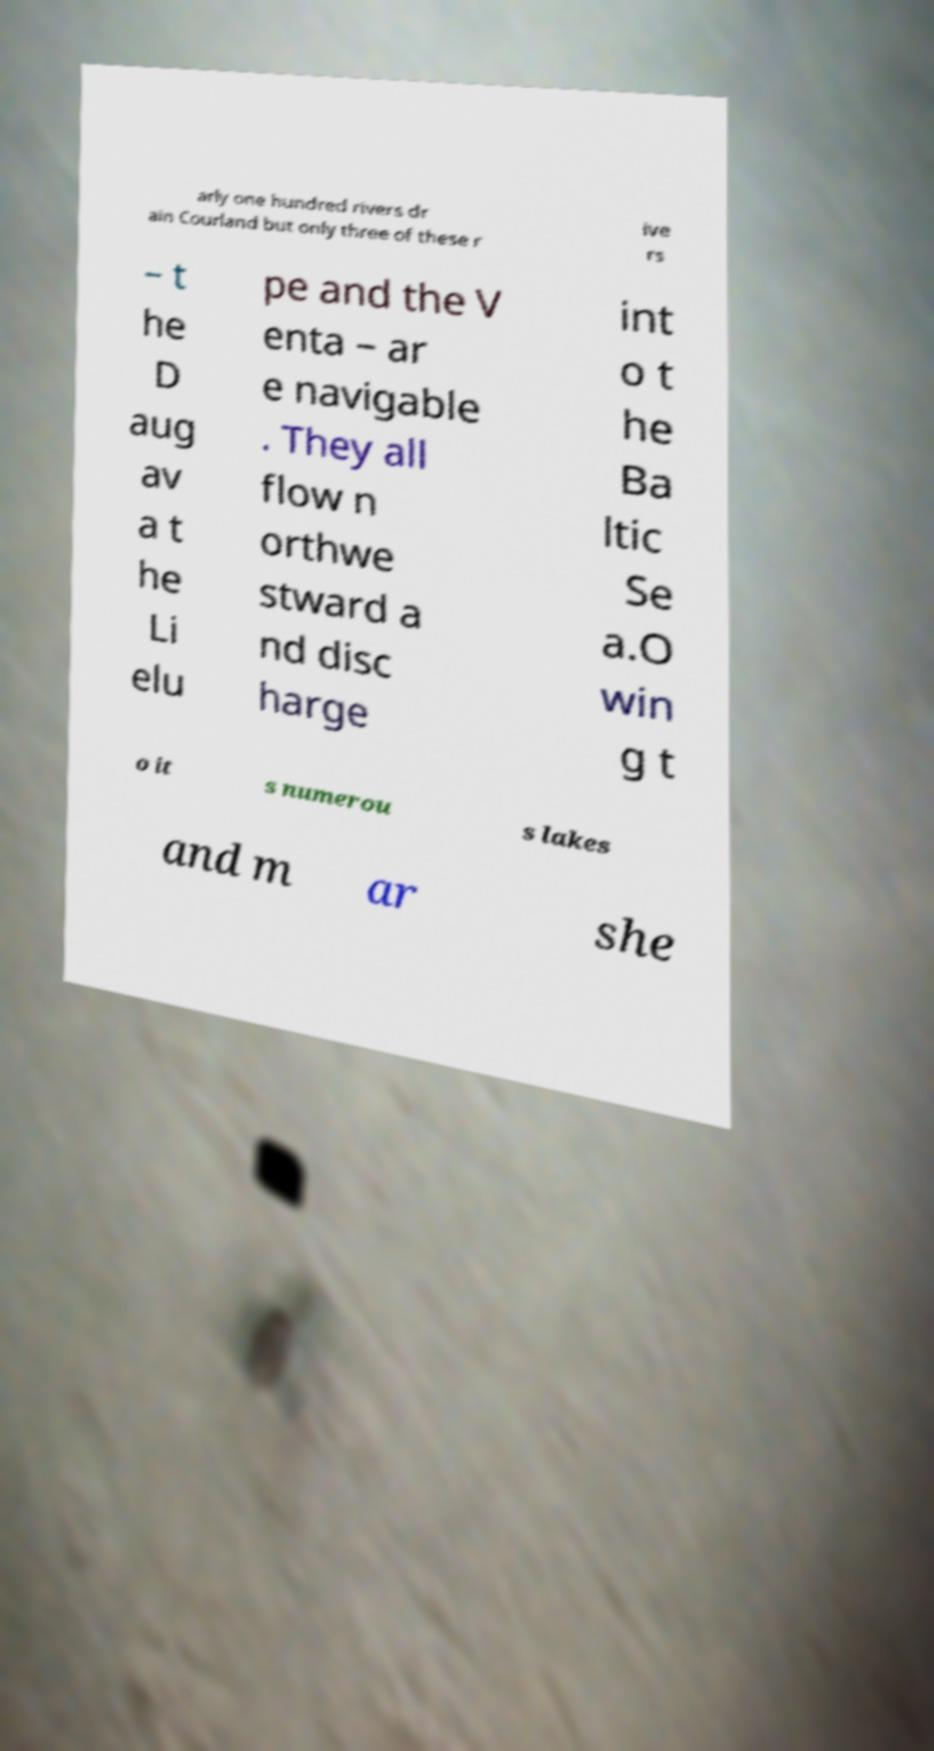Please identify and transcribe the text found in this image. arly one hundred rivers dr ain Courland but only three of these r ive rs – t he D aug av a t he Li elu pe and the V enta – ar e navigable . They all flow n orthwe stward a nd disc harge int o t he Ba ltic Se a.O win g t o it s numerou s lakes and m ar she 